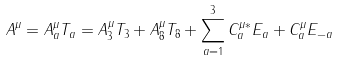<formula> <loc_0><loc_0><loc_500><loc_500>A ^ { \mu } = A _ { a } ^ { \mu } T _ { a } = A _ { 3 } ^ { \mu } T _ { 3 } + A _ { 8 } ^ { \mu } T _ { 8 } + \sum _ { a = 1 } ^ { 3 } C _ { a } ^ { \mu \ast } E _ { a } + C _ { a } ^ { \mu } E _ { - a }</formula> 